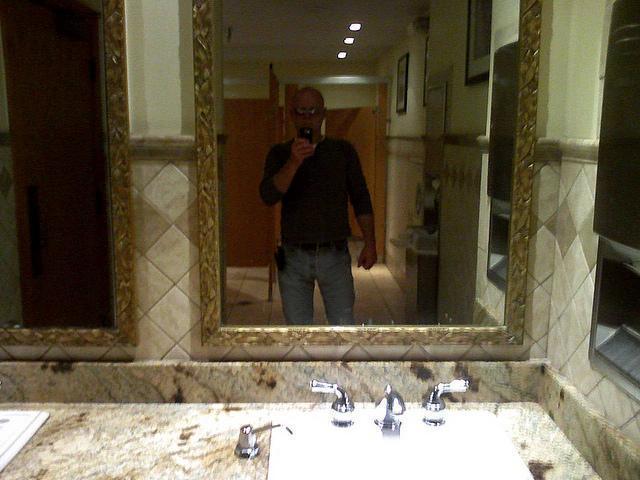How many heads are there?
Give a very brief answer. 1. 